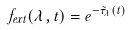Convert formula to latex. <formula><loc_0><loc_0><loc_500><loc_500>f _ { e x t } ( \lambda , t ) = e ^ { - \tilde { \tau } _ { \lambda } ( t ) }</formula> 